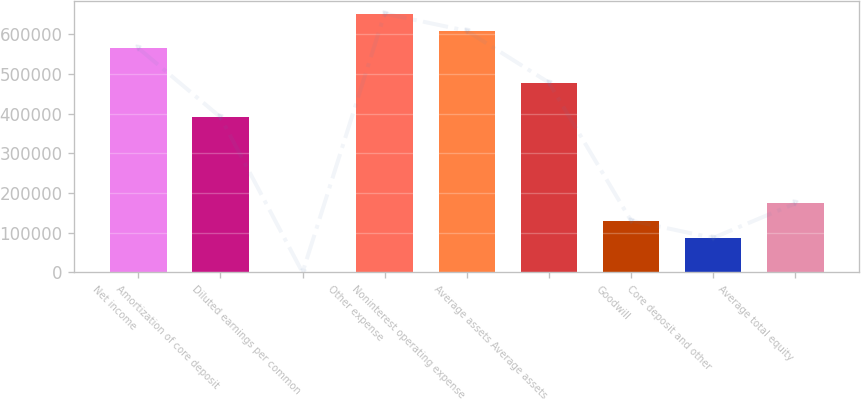<chart> <loc_0><loc_0><loc_500><loc_500><bar_chart><fcel>Net income<fcel>Amortization of core deposit<fcel>Diluted earnings per common<fcel>Other expense<fcel>Noninterest operating expense<fcel>Average assets Average assets<fcel>Goodwill<fcel>Core deposit and other<fcel>Average total equity<nl><fcel>565192<fcel>391287<fcel>0.82<fcel>652144<fcel>608668<fcel>478239<fcel>130429<fcel>86953.3<fcel>173906<nl></chart> 